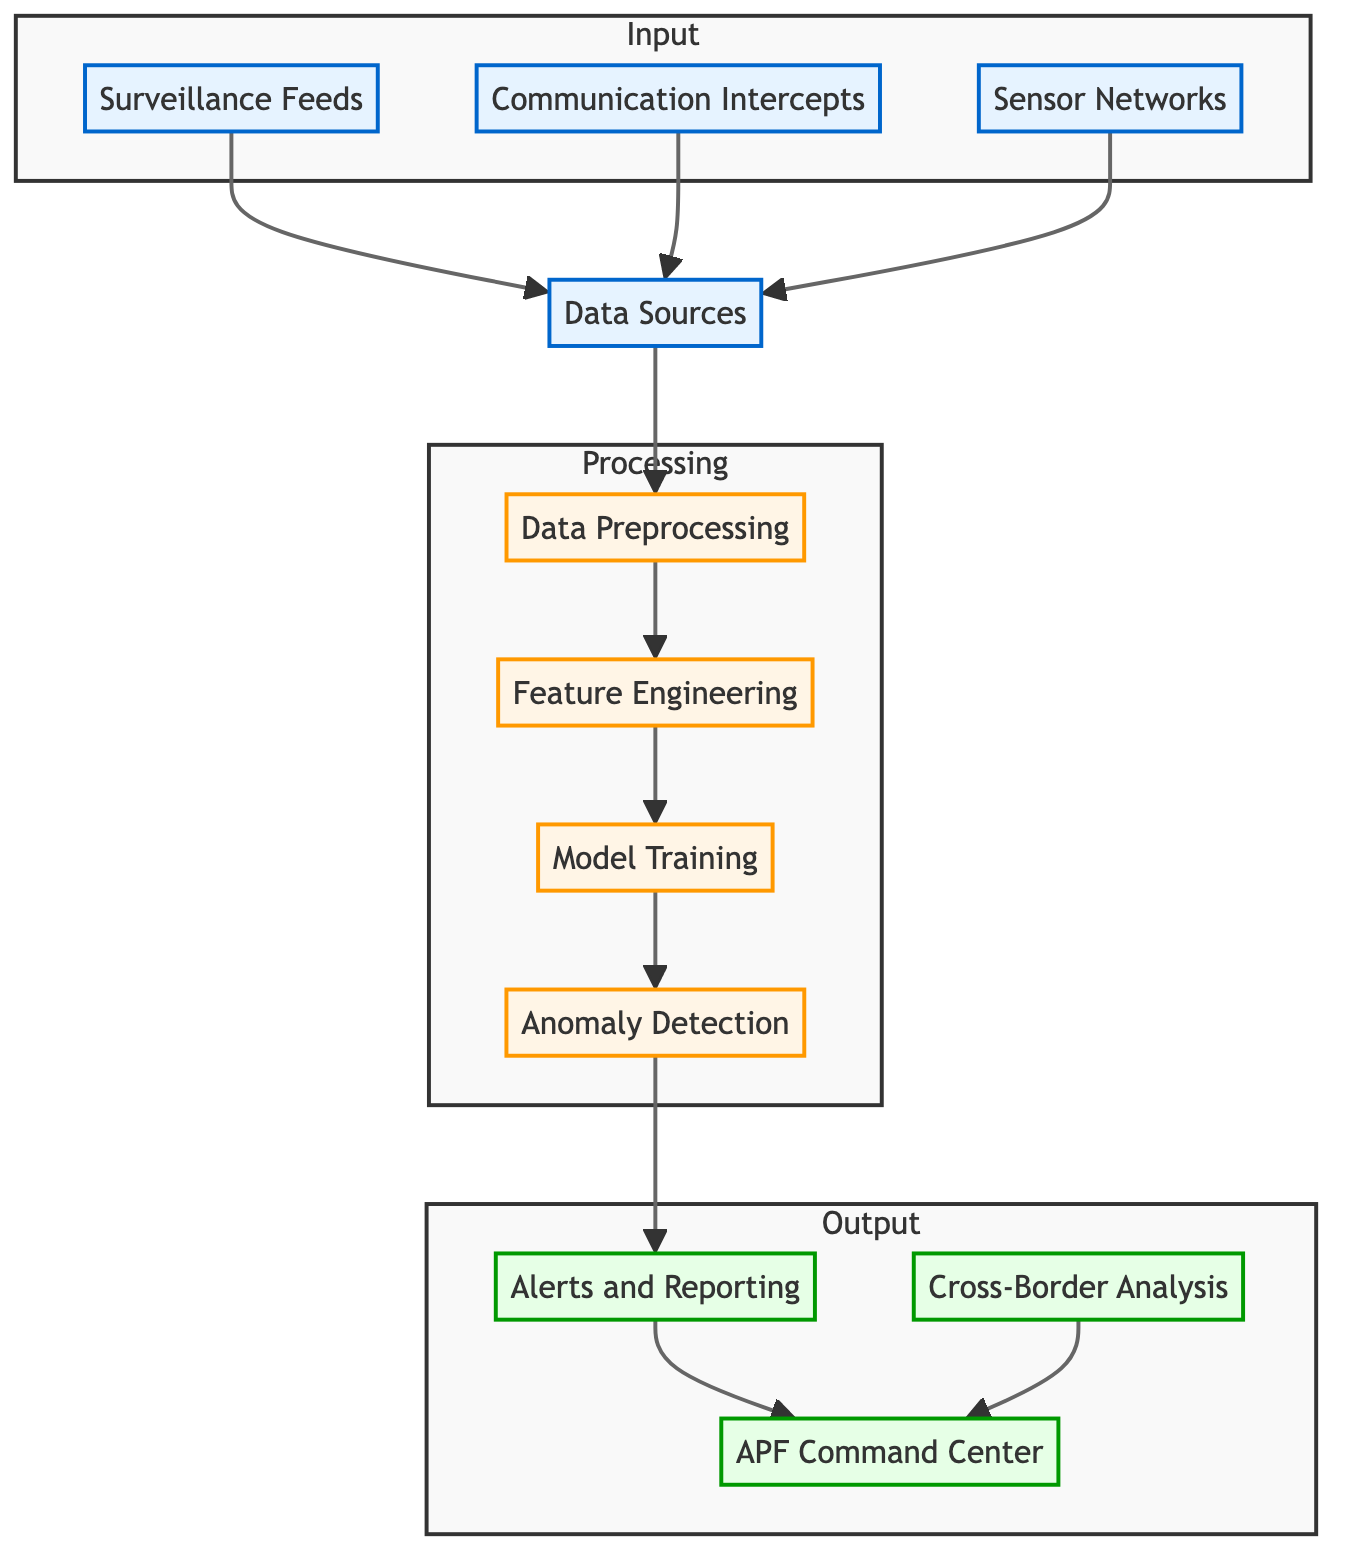What's the first node in the diagram? The flowchart begins with the "Data Sources" node, which is the entry point for all input data.
Answer: Data Sources How many nodes are there in the "Processing" subgraph? The "Processing" subgraph contains four nodes, which are data preprocessing, feature engineering, model training, and anomaly detection.
Answer: Four What type of feeds are used as input in this system? There are three types of feeds: surveillance feeds, communication intercepts, and sensor networks.
Answer: Surveillance feeds, communication intercepts, sensor networks Which node directly follows "Feature Engineering"? The node that directly follows "Feature Engineering" is "Model Training."
Answer: Model Training What is the last output node in the diagram? The last output node in the diagram is "Cross-Border Analysis."
Answer: Cross-Border Analysis How does "Alerts and Reporting" connect to the other nodes? "Alerts and Reporting" directly connects to the "Anomaly Detection" node and then links to "APF Command Center."
Answer: Directly connects to Anomaly Detection What is the relationship between "Data Sources" and "Data Preprocessing"? "Data Sources" feeds into "Data Preprocessing," indicating that the preprocessing takes place after data is gathered from different sources.
Answer: Feeds into How many input nodes are there in total? There are three input nodes as part of the "Input" subgraph: surveillance feeds, communication intercepts, and sensor networks.
Answer: Three What is the purpose of the "Anomaly Detection" node? The "Anomaly Detection" node's purpose is to identify unexpected patterns or behaviors from the processed data, which is crucial for monitoring cross-border activities effectively.
Answer: Identify unexpected patterns What outputs are generated from the "Alerts and Reporting" node? The outputs from "Alerts and Reporting" include notifications directly sent to the "APF Command Center" and further analysis for "Cross-Border Analysis."
Answer: Notifications to APF Command Center and Cross-Border Analysis 